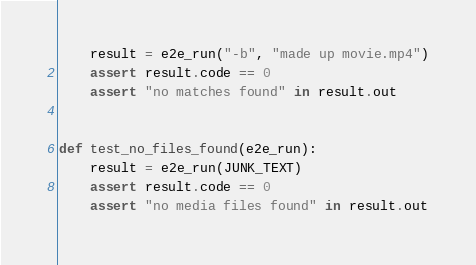<code> <loc_0><loc_0><loc_500><loc_500><_Python_>    result = e2e_run("-b", "made up movie.mp4")
    assert result.code == 0
    assert "no matches found" in result.out


def test_no_files_found(e2e_run):
    result = e2e_run(JUNK_TEXT)
    assert result.code == 0
    assert "no media files found" in result.out
</code> 